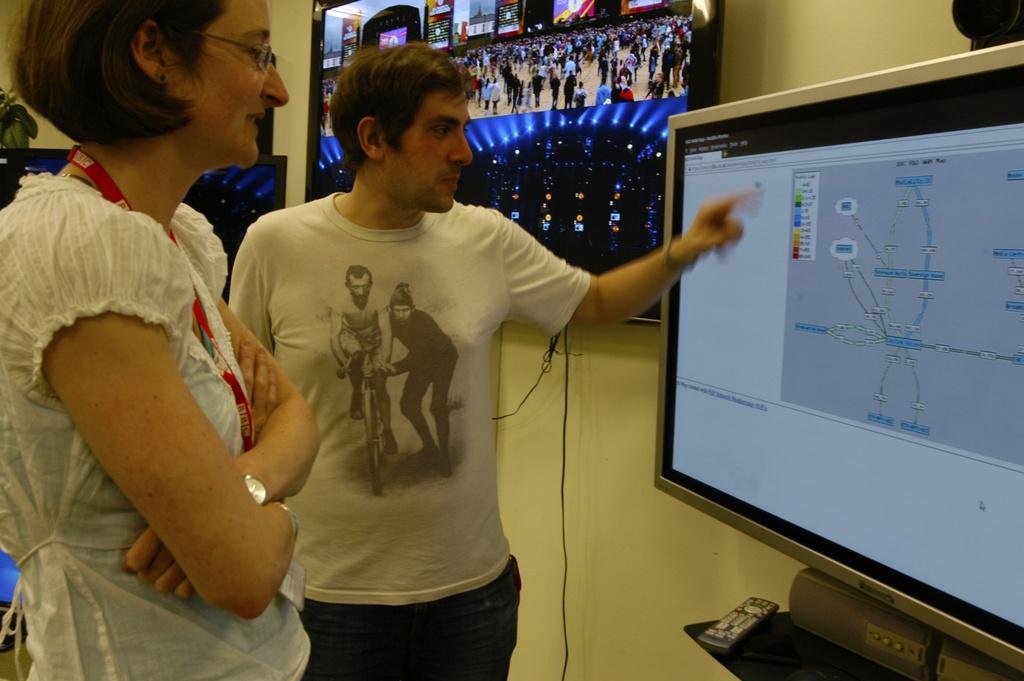Can you describe this image briefly? In this image we can see a man and a woman standing and watching the display screen which is placed on the counter. In the background there is another screen attached to the plain wall. Image also consists of a remote. 